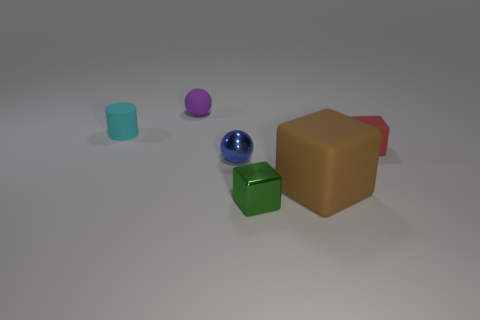Does the image appear to be a photograph or a digital rendering, and what indicates that? The image appears to be a digital rendering. Indicators include the uniform lighting, the lack of shadows and texture disparities, and the perfect geometric shapes of the objects. 